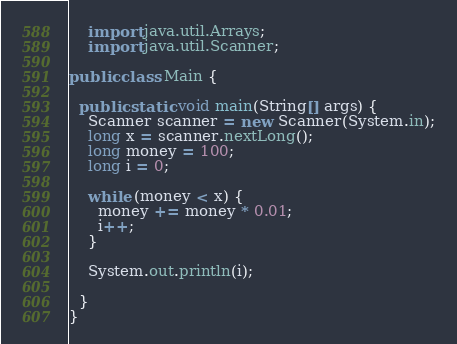Convert code to text. <code><loc_0><loc_0><loc_500><loc_500><_Java_>
    import java.util.Arrays;
    import java.util.Scanner;

public class Main {

  public static void main(String[] args) {
    Scanner scanner = new Scanner(System.in);
    long x = scanner.nextLong();
    long money = 100;
    long i = 0;

    while (money < x) {
      money += money * 0.01;
      i++;
    }

    System.out.println(i);

  }
}
</code> 